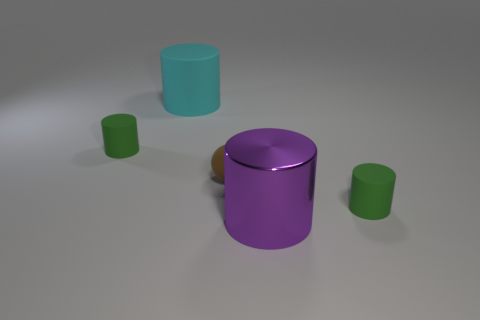Subtract all red spheres. How many green cylinders are left? 2 Add 3 large matte objects. How many objects exist? 8 Subtract all big purple metal cylinders. How many cylinders are left? 3 Subtract all cyan cylinders. How many cylinders are left? 3 Subtract all cylinders. How many objects are left? 1 Subtract all cyan cylinders. Subtract all blue cubes. How many cylinders are left? 3 Subtract all brown balls. Subtract all large purple shiny things. How many objects are left? 3 Add 1 large shiny objects. How many large shiny objects are left? 2 Add 4 tiny brown balls. How many tiny brown balls exist? 5 Subtract 0 yellow balls. How many objects are left? 5 